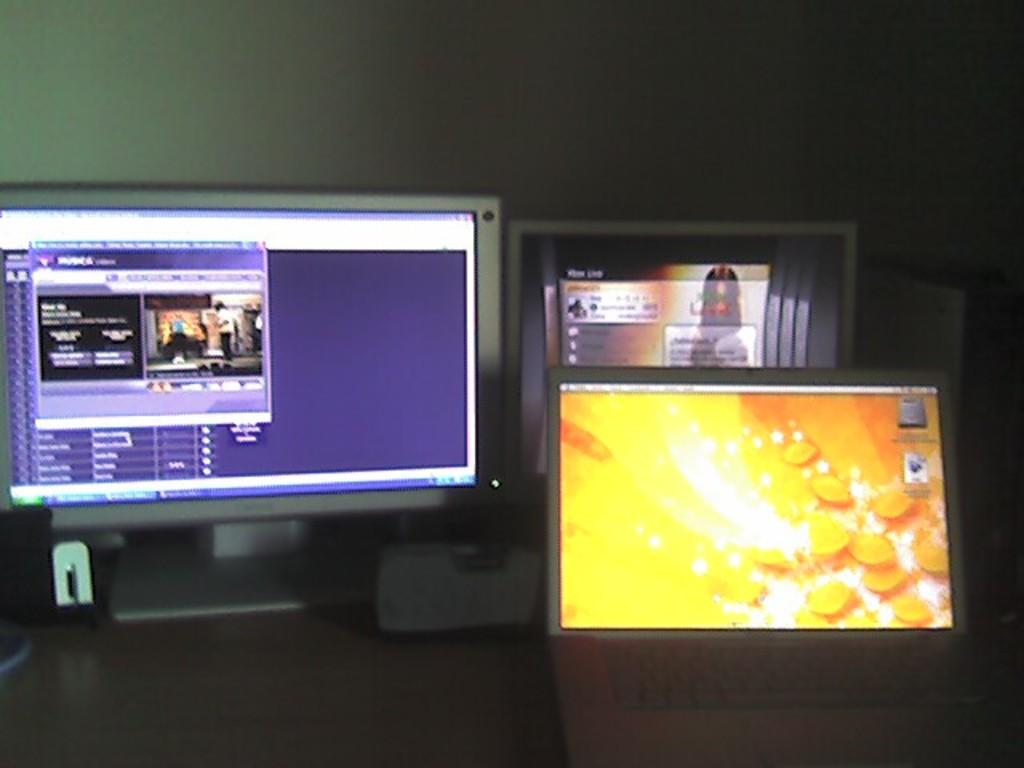What objects are present in the image that display images? There are screens in the image that display images. Where are the screens located? The screens are placed on a surface. What can be seen in the background of the image? There is a wall in the background of the image. Can you tell me how many friends are sitting on the tray in the image? There is no tray or friends present in the image. What type of shade is covering the screens in the image? There is no shade covering the screens in the image; they are displayed without any covering. 